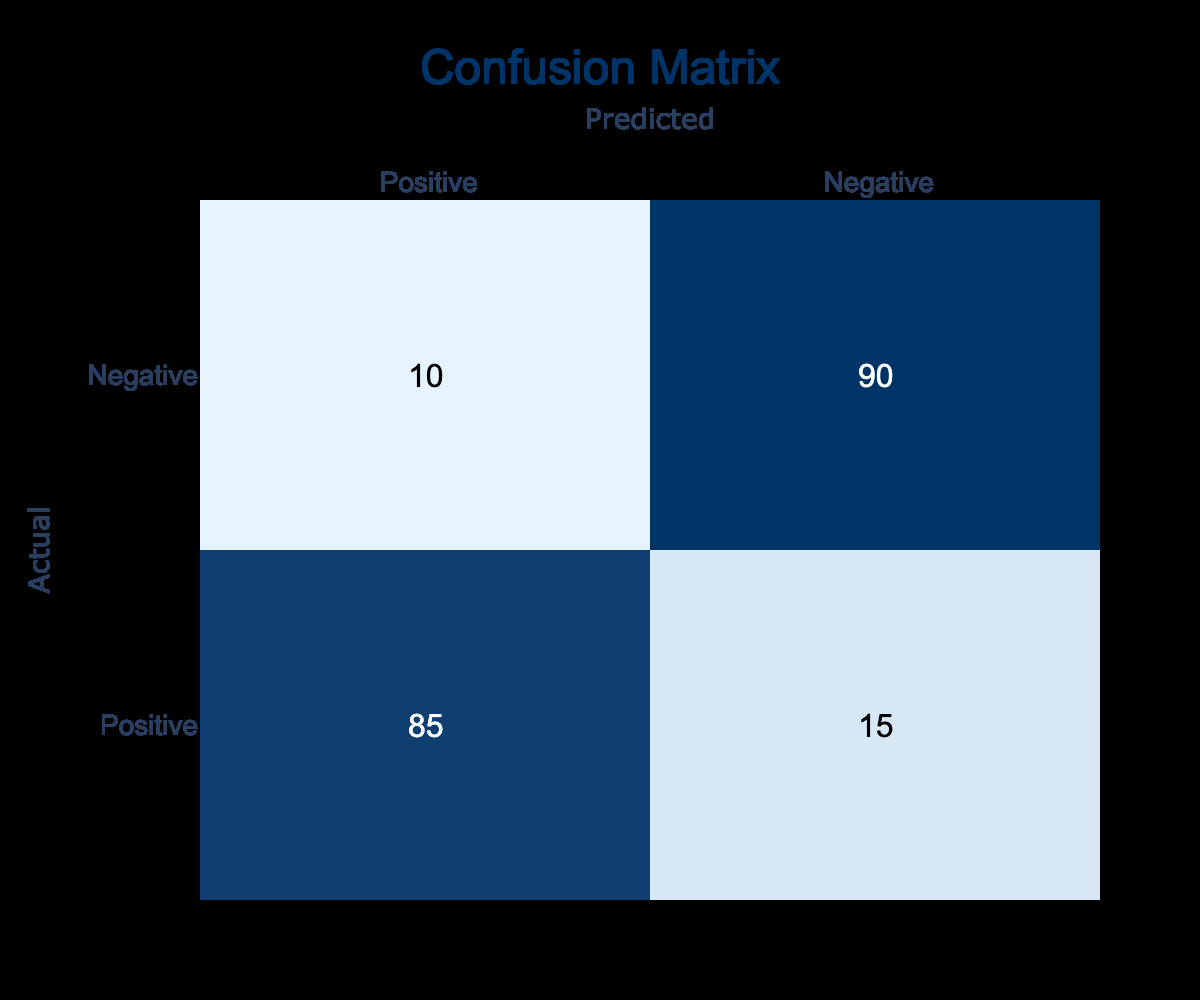What is the number of true positive diagnoses? The number of true positive diagnoses is represented in the 'Positive' row under the 'Positive' column. This value is 85.
Answer: 85 What is the total number of actual positive cases? To find the total number of actual positive cases, we sum the values in the 'Positive' row: 85 + 15 = 100.
Answer: 100 What is the accuracy of the medical imaging system? Accuracy is calculated as (True Positives + True Negatives) / Total Cases. Here, it is (85 + 90) / (85 + 15 + 10 + 90) = 175 / 200 = 0.875 or 87.5%.
Answer: 87.5% Is the system better at detecting positive or negative cases? To determine this, we compare true positives (85) against true negatives (90). Since 90 is higher, the system is better at detecting negative cases.
Answer: Yes What is the rate of false negatives? False negatives are found in the 'Negative' row under the 'Positive' column, which shows 10. The false negative rate can also be calculated as False Negatives / Actual Positives = 10 / 100 = 0.1 or 10%.
Answer: 10 If we consider the false positive rate, what is its value? The false positive count is found in the 'Positive' row under the 'Negative' column, which shows 15. The false positive rate is calculated as False Positives / Actual Negatives = 15 / (15 + 90) = 15 / 105 = 0.142857 or approximately 14.3%.
Answer: 14.3% How many predictions were made in total? Total predictions are the sum of all values in the matrix: 85 + 15 + 10 + 90 = 200.
Answer: 200 What is the proportion of correct diagnoses out of total predictions? This proportion is calculated as (True Positives + True Negatives) / Total Predictions. Here it is (85 + 90) / 200 = 175 / 200 = 0.875, which means 87.5% of predictions are correct.
Answer: 87.5% What is the number of false positives? False positives are represented in the 'Positive' row under the 'Negative' column, which is 15.
Answer: 15 